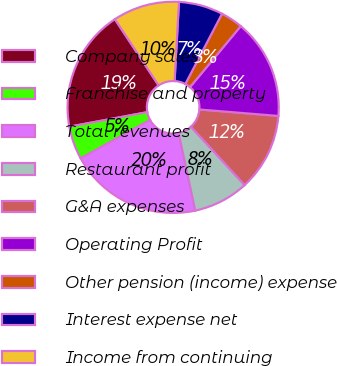<chart> <loc_0><loc_0><loc_500><loc_500><pie_chart><fcel>Company sales<fcel>Franchise and property<fcel>Total revenues<fcel>Restaurant profit<fcel>G&A expenses<fcel>Operating Profit<fcel>Other pension (income) expense<fcel>Interest expense net<fcel>Income from continuing<nl><fcel>18.64%<fcel>5.09%<fcel>20.33%<fcel>8.48%<fcel>11.86%<fcel>15.25%<fcel>3.39%<fcel>6.78%<fcel>10.17%<nl></chart> 